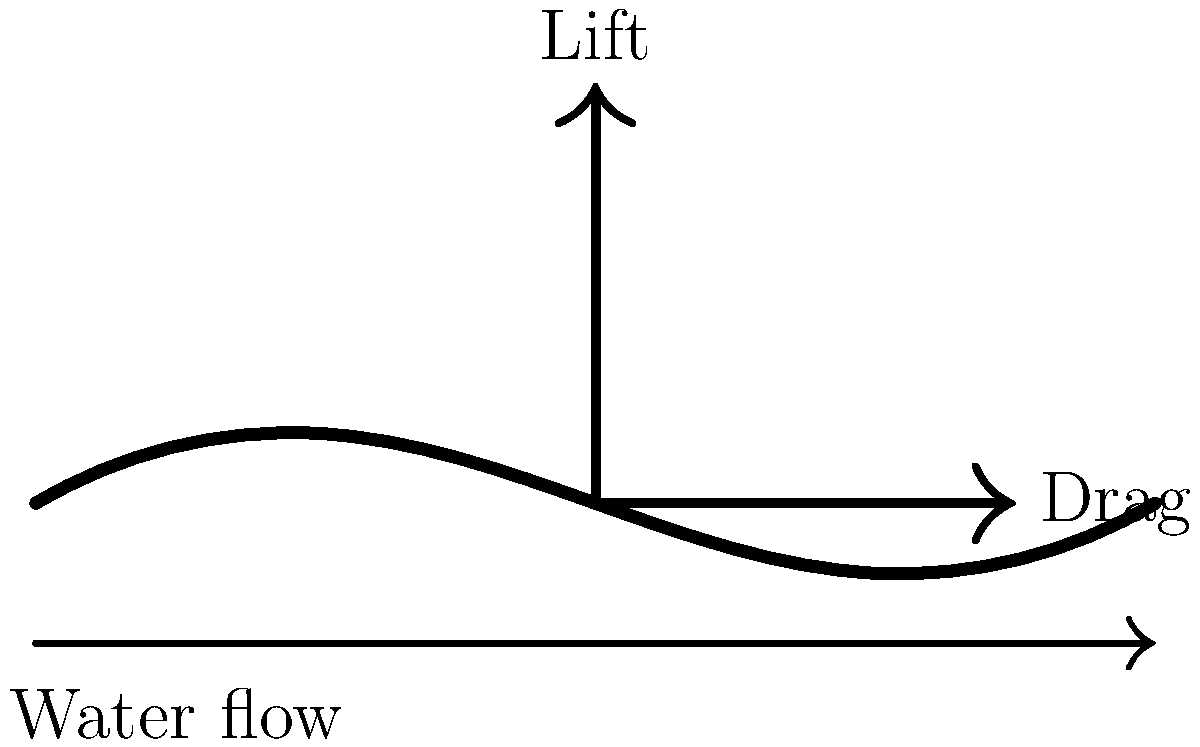During the pull phase of swimming, which force component contributes more to propulsion: lift or drag? To understand the force distribution on a swimmer's hand during the pull phase, we need to consider the following steps:

1. Identify the forces: The two main forces acting on the hand are lift and drag.

2. Understand lift force:
   - Lift force acts perpendicular to the direction of water flow.
   - It is generated by the pressure difference between the top and bottom of the hand.
   - In swimming, lift force primarily moves the body upward.

3. Understand drag force:
   - Drag force acts parallel to the direction of water flow.
   - It is created by the resistance of water against the hand's motion.
   - In swimming, drag force primarily moves the body forward.

4. Consider the pull phase:
   - During the pull phase, the hand moves backward relative to the body.
   - The angle of the hand creates both lift and drag forces.

5. Analyze propulsion:
   - Propulsion is the force that moves the swimmer forward.
   - Drag force directly contributes to forward motion.
   - Lift force mainly contributes to keeping the body position high in the water.

6. Compare contributions:
   - While both forces are important, drag force is more directly aligned with the desired direction of motion.
   - Drag force provides the primary propulsive force during the pull phase.

Therefore, during the pull phase of swimming, the drag force component contributes more to propulsion than the lift force.
Answer: Drag force 